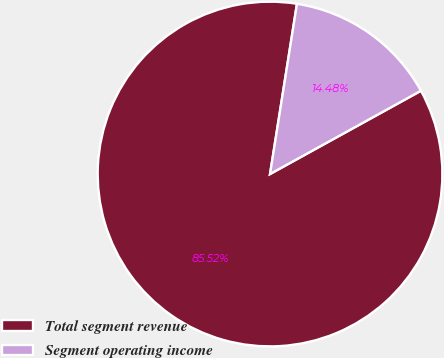Convert chart to OTSL. <chart><loc_0><loc_0><loc_500><loc_500><pie_chart><fcel>Total segment revenue<fcel>Segment operating income<nl><fcel>85.52%<fcel>14.48%<nl></chart> 